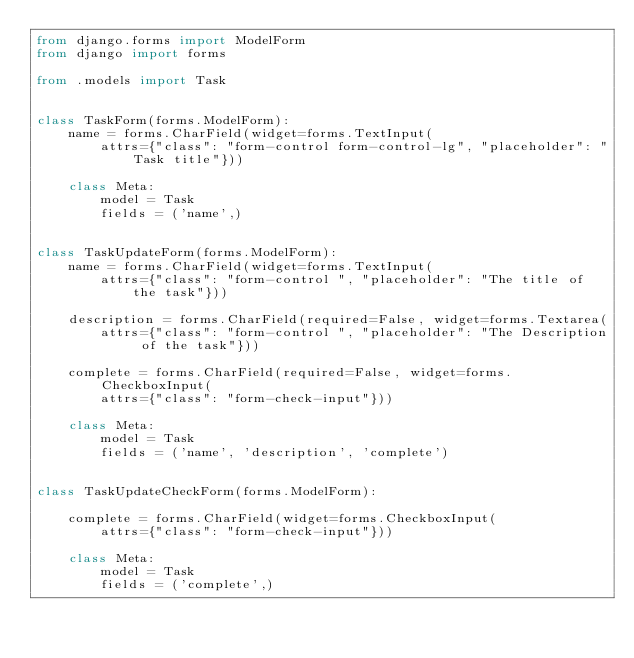<code> <loc_0><loc_0><loc_500><loc_500><_Python_>from django.forms import ModelForm
from django import forms

from .models import Task


class TaskForm(forms.ModelForm):
    name = forms.CharField(widget=forms.TextInput(
        attrs={"class": "form-control form-control-lg", "placeholder": "Task title"}))

    class Meta:
        model = Task
        fields = ('name',)


class TaskUpdateForm(forms.ModelForm):
    name = forms.CharField(widget=forms.TextInput(
        attrs={"class": "form-control ", "placeholder": "The title of the task"}))

    description = forms.CharField(required=False, widget=forms.Textarea(
        attrs={"class": "form-control ", "placeholder": "The Description of the task"}))

    complete = forms.CharField(required=False, widget=forms.CheckboxInput(
        attrs={"class": "form-check-input"}))

    class Meta:
        model = Task
        fields = ('name', 'description', 'complete')


class TaskUpdateCheckForm(forms.ModelForm):

    complete = forms.CharField(widget=forms.CheckboxInput(
        attrs={"class": "form-check-input"}))

    class Meta:
        model = Task
        fields = ('complete',)
</code> 